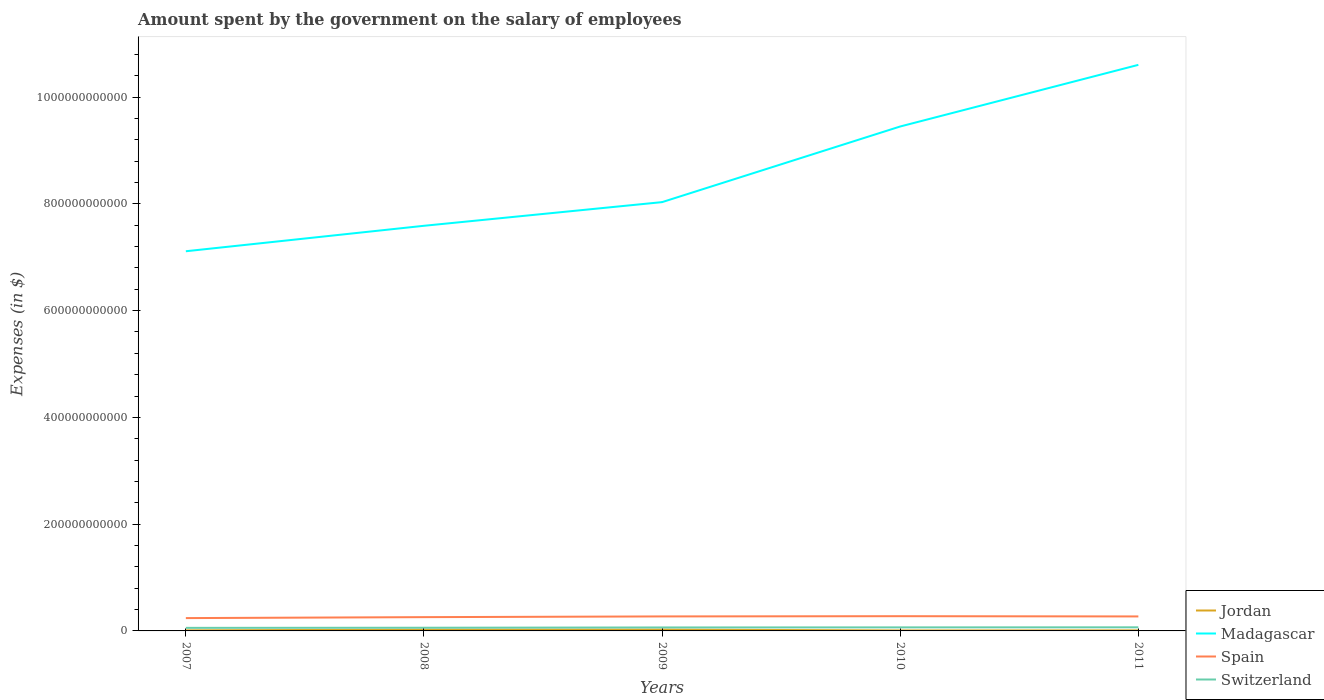How many different coloured lines are there?
Provide a short and direct response. 4. Is the number of lines equal to the number of legend labels?
Make the answer very short. Yes. Across all years, what is the maximum amount spent on the salary of employees by the government in Spain?
Offer a very short reply. 2.40e+1. What is the total amount spent on the salary of employees by the government in Jordan in the graph?
Your answer should be compact. 1.52e+09. What is the difference between the highest and the second highest amount spent on the salary of employees by the government in Spain?
Make the answer very short. 3.58e+09. What is the difference between the highest and the lowest amount spent on the salary of employees by the government in Switzerland?
Provide a short and direct response. 3. How many years are there in the graph?
Your response must be concise. 5. What is the difference between two consecutive major ticks on the Y-axis?
Ensure brevity in your answer.  2.00e+11. Are the values on the major ticks of Y-axis written in scientific E-notation?
Ensure brevity in your answer.  No. Does the graph contain any zero values?
Your answer should be very brief. No. Does the graph contain grids?
Your answer should be very brief. No. What is the title of the graph?
Provide a succinct answer. Amount spent by the government on the salary of employees. Does "Serbia" appear as one of the legend labels in the graph?
Your answer should be compact. No. What is the label or title of the X-axis?
Ensure brevity in your answer.  Years. What is the label or title of the Y-axis?
Offer a terse response. Expenses (in $). What is the Expenses (in $) in Jordan in 2007?
Provide a short and direct response. 1.07e+09. What is the Expenses (in $) in Madagascar in 2007?
Offer a terse response. 7.11e+11. What is the Expenses (in $) of Spain in 2007?
Your answer should be compact. 2.40e+1. What is the Expenses (in $) in Switzerland in 2007?
Your answer should be very brief. 5.73e+09. What is the Expenses (in $) of Jordan in 2008?
Make the answer very short. 2.39e+09. What is the Expenses (in $) of Madagascar in 2008?
Your answer should be very brief. 7.59e+11. What is the Expenses (in $) of Spain in 2008?
Provide a short and direct response. 2.58e+1. What is the Expenses (in $) in Switzerland in 2008?
Keep it short and to the point. 5.96e+09. What is the Expenses (in $) of Jordan in 2009?
Provide a succinct answer. 2.53e+09. What is the Expenses (in $) of Madagascar in 2009?
Your answer should be compact. 8.03e+11. What is the Expenses (in $) of Spain in 2009?
Ensure brevity in your answer.  2.71e+1. What is the Expenses (in $) in Switzerland in 2009?
Keep it short and to the point. 6.48e+09. What is the Expenses (in $) of Jordan in 2010?
Offer a very short reply. 8.84e+08. What is the Expenses (in $) of Madagascar in 2010?
Ensure brevity in your answer.  9.45e+11. What is the Expenses (in $) in Spain in 2010?
Offer a terse response. 2.76e+1. What is the Expenses (in $) in Switzerland in 2010?
Give a very brief answer. 6.65e+09. What is the Expenses (in $) of Jordan in 2011?
Give a very brief answer. 1.01e+09. What is the Expenses (in $) of Madagascar in 2011?
Provide a succinct answer. 1.06e+12. What is the Expenses (in $) of Spain in 2011?
Ensure brevity in your answer.  2.71e+1. What is the Expenses (in $) in Switzerland in 2011?
Provide a succinct answer. 6.75e+09. Across all years, what is the maximum Expenses (in $) of Jordan?
Make the answer very short. 2.53e+09. Across all years, what is the maximum Expenses (in $) of Madagascar?
Give a very brief answer. 1.06e+12. Across all years, what is the maximum Expenses (in $) of Spain?
Provide a short and direct response. 2.76e+1. Across all years, what is the maximum Expenses (in $) of Switzerland?
Provide a succinct answer. 6.75e+09. Across all years, what is the minimum Expenses (in $) of Jordan?
Offer a very short reply. 8.84e+08. Across all years, what is the minimum Expenses (in $) in Madagascar?
Give a very brief answer. 7.11e+11. Across all years, what is the minimum Expenses (in $) of Spain?
Provide a short and direct response. 2.40e+1. Across all years, what is the minimum Expenses (in $) in Switzerland?
Your answer should be compact. 5.73e+09. What is the total Expenses (in $) of Jordan in the graph?
Offer a terse response. 7.89e+09. What is the total Expenses (in $) of Madagascar in the graph?
Make the answer very short. 4.28e+12. What is the total Expenses (in $) of Spain in the graph?
Make the answer very short. 1.32e+11. What is the total Expenses (in $) of Switzerland in the graph?
Make the answer very short. 3.16e+1. What is the difference between the Expenses (in $) of Jordan in 2007 and that in 2008?
Your response must be concise. -1.32e+09. What is the difference between the Expenses (in $) of Madagascar in 2007 and that in 2008?
Keep it short and to the point. -4.77e+1. What is the difference between the Expenses (in $) in Spain in 2007 and that in 2008?
Provide a short and direct response. -1.80e+09. What is the difference between the Expenses (in $) of Switzerland in 2007 and that in 2008?
Provide a short and direct response. -2.25e+08. What is the difference between the Expenses (in $) of Jordan in 2007 and that in 2009?
Your response must be concise. -1.47e+09. What is the difference between the Expenses (in $) in Madagascar in 2007 and that in 2009?
Provide a short and direct response. -9.20e+1. What is the difference between the Expenses (in $) of Spain in 2007 and that in 2009?
Your answer should be compact. -3.12e+09. What is the difference between the Expenses (in $) of Switzerland in 2007 and that in 2009?
Ensure brevity in your answer.  -7.49e+08. What is the difference between the Expenses (in $) in Jordan in 2007 and that in 2010?
Keep it short and to the point. 1.84e+08. What is the difference between the Expenses (in $) in Madagascar in 2007 and that in 2010?
Your answer should be very brief. -2.34e+11. What is the difference between the Expenses (in $) in Spain in 2007 and that in 2010?
Give a very brief answer. -3.58e+09. What is the difference between the Expenses (in $) of Switzerland in 2007 and that in 2010?
Your response must be concise. -9.15e+08. What is the difference between the Expenses (in $) in Jordan in 2007 and that in 2011?
Make the answer very short. 5.42e+07. What is the difference between the Expenses (in $) in Madagascar in 2007 and that in 2011?
Keep it short and to the point. -3.49e+11. What is the difference between the Expenses (in $) of Spain in 2007 and that in 2011?
Your answer should be very brief. -3.12e+09. What is the difference between the Expenses (in $) of Switzerland in 2007 and that in 2011?
Offer a very short reply. -1.01e+09. What is the difference between the Expenses (in $) in Jordan in 2008 and that in 2009?
Keep it short and to the point. -1.44e+08. What is the difference between the Expenses (in $) in Madagascar in 2008 and that in 2009?
Offer a terse response. -4.43e+1. What is the difference between the Expenses (in $) in Spain in 2008 and that in 2009?
Your answer should be very brief. -1.32e+09. What is the difference between the Expenses (in $) of Switzerland in 2008 and that in 2009?
Your response must be concise. -5.24e+08. What is the difference between the Expenses (in $) of Jordan in 2008 and that in 2010?
Your answer should be compact. 1.50e+09. What is the difference between the Expenses (in $) in Madagascar in 2008 and that in 2010?
Make the answer very short. -1.86e+11. What is the difference between the Expenses (in $) of Spain in 2008 and that in 2010?
Provide a short and direct response. -1.78e+09. What is the difference between the Expenses (in $) in Switzerland in 2008 and that in 2010?
Your answer should be compact. -6.91e+08. What is the difference between the Expenses (in $) of Jordan in 2008 and that in 2011?
Your response must be concise. 1.38e+09. What is the difference between the Expenses (in $) of Madagascar in 2008 and that in 2011?
Make the answer very short. -3.01e+11. What is the difference between the Expenses (in $) in Spain in 2008 and that in 2011?
Your response must be concise. -1.32e+09. What is the difference between the Expenses (in $) in Switzerland in 2008 and that in 2011?
Offer a very short reply. -7.88e+08. What is the difference between the Expenses (in $) of Jordan in 2009 and that in 2010?
Your answer should be very brief. 1.65e+09. What is the difference between the Expenses (in $) of Madagascar in 2009 and that in 2010?
Make the answer very short. -1.42e+11. What is the difference between the Expenses (in $) in Spain in 2009 and that in 2010?
Your answer should be compact. -4.54e+08. What is the difference between the Expenses (in $) of Switzerland in 2009 and that in 2010?
Provide a succinct answer. -1.66e+08. What is the difference between the Expenses (in $) of Jordan in 2009 and that in 2011?
Your response must be concise. 1.52e+09. What is the difference between the Expenses (in $) in Madagascar in 2009 and that in 2011?
Offer a terse response. -2.57e+11. What is the difference between the Expenses (in $) of Spain in 2009 and that in 2011?
Offer a terse response. 9.00e+06. What is the difference between the Expenses (in $) of Switzerland in 2009 and that in 2011?
Ensure brevity in your answer.  -2.64e+08. What is the difference between the Expenses (in $) of Jordan in 2010 and that in 2011?
Your response must be concise. -1.30e+08. What is the difference between the Expenses (in $) of Madagascar in 2010 and that in 2011?
Your answer should be compact. -1.15e+11. What is the difference between the Expenses (in $) in Spain in 2010 and that in 2011?
Your answer should be very brief. 4.63e+08. What is the difference between the Expenses (in $) of Switzerland in 2010 and that in 2011?
Give a very brief answer. -9.73e+07. What is the difference between the Expenses (in $) of Jordan in 2007 and the Expenses (in $) of Madagascar in 2008?
Your answer should be compact. -7.58e+11. What is the difference between the Expenses (in $) in Jordan in 2007 and the Expenses (in $) in Spain in 2008?
Provide a succinct answer. -2.48e+1. What is the difference between the Expenses (in $) of Jordan in 2007 and the Expenses (in $) of Switzerland in 2008?
Offer a very short reply. -4.89e+09. What is the difference between the Expenses (in $) of Madagascar in 2007 and the Expenses (in $) of Spain in 2008?
Keep it short and to the point. 6.85e+11. What is the difference between the Expenses (in $) of Madagascar in 2007 and the Expenses (in $) of Switzerland in 2008?
Offer a very short reply. 7.05e+11. What is the difference between the Expenses (in $) in Spain in 2007 and the Expenses (in $) in Switzerland in 2008?
Your response must be concise. 1.81e+1. What is the difference between the Expenses (in $) in Jordan in 2007 and the Expenses (in $) in Madagascar in 2009?
Your answer should be compact. -8.02e+11. What is the difference between the Expenses (in $) in Jordan in 2007 and the Expenses (in $) in Spain in 2009?
Ensure brevity in your answer.  -2.61e+1. What is the difference between the Expenses (in $) of Jordan in 2007 and the Expenses (in $) of Switzerland in 2009?
Ensure brevity in your answer.  -5.42e+09. What is the difference between the Expenses (in $) in Madagascar in 2007 and the Expenses (in $) in Spain in 2009?
Your answer should be very brief. 6.84e+11. What is the difference between the Expenses (in $) in Madagascar in 2007 and the Expenses (in $) in Switzerland in 2009?
Your response must be concise. 7.05e+11. What is the difference between the Expenses (in $) of Spain in 2007 and the Expenses (in $) of Switzerland in 2009?
Offer a terse response. 1.75e+1. What is the difference between the Expenses (in $) in Jordan in 2007 and the Expenses (in $) in Madagascar in 2010?
Make the answer very short. -9.44e+11. What is the difference between the Expenses (in $) in Jordan in 2007 and the Expenses (in $) in Spain in 2010?
Offer a very short reply. -2.65e+1. What is the difference between the Expenses (in $) of Jordan in 2007 and the Expenses (in $) of Switzerland in 2010?
Your answer should be compact. -5.58e+09. What is the difference between the Expenses (in $) of Madagascar in 2007 and the Expenses (in $) of Spain in 2010?
Keep it short and to the point. 6.84e+11. What is the difference between the Expenses (in $) in Madagascar in 2007 and the Expenses (in $) in Switzerland in 2010?
Your answer should be very brief. 7.05e+11. What is the difference between the Expenses (in $) in Spain in 2007 and the Expenses (in $) in Switzerland in 2010?
Ensure brevity in your answer.  1.74e+1. What is the difference between the Expenses (in $) in Jordan in 2007 and the Expenses (in $) in Madagascar in 2011?
Provide a short and direct response. -1.06e+12. What is the difference between the Expenses (in $) of Jordan in 2007 and the Expenses (in $) of Spain in 2011?
Ensure brevity in your answer.  -2.61e+1. What is the difference between the Expenses (in $) in Jordan in 2007 and the Expenses (in $) in Switzerland in 2011?
Your answer should be very brief. -5.68e+09. What is the difference between the Expenses (in $) in Madagascar in 2007 and the Expenses (in $) in Spain in 2011?
Your response must be concise. 6.84e+11. What is the difference between the Expenses (in $) in Madagascar in 2007 and the Expenses (in $) in Switzerland in 2011?
Your answer should be compact. 7.04e+11. What is the difference between the Expenses (in $) of Spain in 2007 and the Expenses (in $) of Switzerland in 2011?
Provide a succinct answer. 1.73e+1. What is the difference between the Expenses (in $) of Jordan in 2008 and the Expenses (in $) of Madagascar in 2009?
Your response must be concise. -8.01e+11. What is the difference between the Expenses (in $) in Jordan in 2008 and the Expenses (in $) in Spain in 2009?
Provide a short and direct response. -2.48e+1. What is the difference between the Expenses (in $) in Jordan in 2008 and the Expenses (in $) in Switzerland in 2009?
Ensure brevity in your answer.  -4.10e+09. What is the difference between the Expenses (in $) of Madagascar in 2008 and the Expenses (in $) of Spain in 2009?
Provide a short and direct response. 7.32e+11. What is the difference between the Expenses (in $) in Madagascar in 2008 and the Expenses (in $) in Switzerland in 2009?
Your answer should be very brief. 7.52e+11. What is the difference between the Expenses (in $) in Spain in 2008 and the Expenses (in $) in Switzerland in 2009?
Provide a succinct answer. 1.93e+1. What is the difference between the Expenses (in $) in Jordan in 2008 and the Expenses (in $) in Madagascar in 2010?
Offer a very short reply. -9.43e+11. What is the difference between the Expenses (in $) of Jordan in 2008 and the Expenses (in $) of Spain in 2010?
Ensure brevity in your answer.  -2.52e+1. What is the difference between the Expenses (in $) in Jordan in 2008 and the Expenses (in $) in Switzerland in 2010?
Your response must be concise. -4.26e+09. What is the difference between the Expenses (in $) in Madagascar in 2008 and the Expenses (in $) in Spain in 2010?
Make the answer very short. 7.31e+11. What is the difference between the Expenses (in $) in Madagascar in 2008 and the Expenses (in $) in Switzerland in 2010?
Ensure brevity in your answer.  7.52e+11. What is the difference between the Expenses (in $) in Spain in 2008 and the Expenses (in $) in Switzerland in 2010?
Provide a short and direct response. 1.92e+1. What is the difference between the Expenses (in $) in Jordan in 2008 and the Expenses (in $) in Madagascar in 2011?
Your answer should be compact. -1.06e+12. What is the difference between the Expenses (in $) in Jordan in 2008 and the Expenses (in $) in Spain in 2011?
Make the answer very short. -2.48e+1. What is the difference between the Expenses (in $) of Jordan in 2008 and the Expenses (in $) of Switzerland in 2011?
Make the answer very short. -4.36e+09. What is the difference between the Expenses (in $) of Madagascar in 2008 and the Expenses (in $) of Spain in 2011?
Keep it short and to the point. 7.32e+11. What is the difference between the Expenses (in $) in Madagascar in 2008 and the Expenses (in $) in Switzerland in 2011?
Provide a short and direct response. 7.52e+11. What is the difference between the Expenses (in $) in Spain in 2008 and the Expenses (in $) in Switzerland in 2011?
Your answer should be compact. 1.91e+1. What is the difference between the Expenses (in $) of Jordan in 2009 and the Expenses (in $) of Madagascar in 2010?
Provide a succinct answer. -9.42e+11. What is the difference between the Expenses (in $) in Jordan in 2009 and the Expenses (in $) in Spain in 2010?
Give a very brief answer. -2.51e+1. What is the difference between the Expenses (in $) in Jordan in 2009 and the Expenses (in $) in Switzerland in 2010?
Provide a succinct answer. -4.12e+09. What is the difference between the Expenses (in $) in Madagascar in 2009 and the Expenses (in $) in Spain in 2010?
Offer a very short reply. 7.76e+11. What is the difference between the Expenses (in $) in Madagascar in 2009 and the Expenses (in $) in Switzerland in 2010?
Your response must be concise. 7.97e+11. What is the difference between the Expenses (in $) in Spain in 2009 and the Expenses (in $) in Switzerland in 2010?
Your response must be concise. 2.05e+1. What is the difference between the Expenses (in $) in Jordan in 2009 and the Expenses (in $) in Madagascar in 2011?
Your response must be concise. -1.06e+12. What is the difference between the Expenses (in $) of Jordan in 2009 and the Expenses (in $) of Spain in 2011?
Keep it short and to the point. -2.46e+1. What is the difference between the Expenses (in $) of Jordan in 2009 and the Expenses (in $) of Switzerland in 2011?
Make the answer very short. -4.21e+09. What is the difference between the Expenses (in $) of Madagascar in 2009 and the Expenses (in $) of Spain in 2011?
Offer a very short reply. 7.76e+11. What is the difference between the Expenses (in $) in Madagascar in 2009 and the Expenses (in $) in Switzerland in 2011?
Keep it short and to the point. 7.96e+11. What is the difference between the Expenses (in $) in Spain in 2009 and the Expenses (in $) in Switzerland in 2011?
Your answer should be very brief. 2.04e+1. What is the difference between the Expenses (in $) of Jordan in 2010 and the Expenses (in $) of Madagascar in 2011?
Provide a succinct answer. -1.06e+12. What is the difference between the Expenses (in $) in Jordan in 2010 and the Expenses (in $) in Spain in 2011?
Make the answer very short. -2.63e+1. What is the difference between the Expenses (in $) of Jordan in 2010 and the Expenses (in $) of Switzerland in 2011?
Ensure brevity in your answer.  -5.86e+09. What is the difference between the Expenses (in $) in Madagascar in 2010 and the Expenses (in $) in Spain in 2011?
Keep it short and to the point. 9.18e+11. What is the difference between the Expenses (in $) of Madagascar in 2010 and the Expenses (in $) of Switzerland in 2011?
Provide a short and direct response. 9.38e+11. What is the difference between the Expenses (in $) of Spain in 2010 and the Expenses (in $) of Switzerland in 2011?
Offer a very short reply. 2.09e+1. What is the average Expenses (in $) in Jordan per year?
Your response must be concise. 1.58e+09. What is the average Expenses (in $) of Madagascar per year?
Offer a terse response. 8.56e+11. What is the average Expenses (in $) in Spain per year?
Your response must be concise. 2.63e+1. What is the average Expenses (in $) of Switzerland per year?
Give a very brief answer. 6.32e+09. In the year 2007, what is the difference between the Expenses (in $) in Jordan and Expenses (in $) in Madagascar?
Offer a very short reply. -7.10e+11. In the year 2007, what is the difference between the Expenses (in $) of Jordan and Expenses (in $) of Spain?
Provide a succinct answer. -2.30e+1. In the year 2007, what is the difference between the Expenses (in $) of Jordan and Expenses (in $) of Switzerland?
Your answer should be very brief. -4.67e+09. In the year 2007, what is the difference between the Expenses (in $) of Madagascar and Expenses (in $) of Spain?
Your answer should be very brief. 6.87e+11. In the year 2007, what is the difference between the Expenses (in $) of Madagascar and Expenses (in $) of Switzerland?
Your answer should be very brief. 7.05e+11. In the year 2007, what is the difference between the Expenses (in $) in Spain and Expenses (in $) in Switzerland?
Your response must be concise. 1.83e+1. In the year 2008, what is the difference between the Expenses (in $) of Jordan and Expenses (in $) of Madagascar?
Offer a terse response. -7.57e+11. In the year 2008, what is the difference between the Expenses (in $) in Jordan and Expenses (in $) in Spain?
Provide a succinct answer. -2.34e+1. In the year 2008, what is the difference between the Expenses (in $) in Jordan and Expenses (in $) in Switzerland?
Give a very brief answer. -3.57e+09. In the year 2008, what is the difference between the Expenses (in $) of Madagascar and Expenses (in $) of Spain?
Offer a very short reply. 7.33e+11. In the year 2008, what is the difference between the Expenses (in $) of Madagascar and Expenses (in $) of Switzerland?
Your answer should be very brief. 7.53e+11. In the year 2008, what is the difference between the Expenses (in $) of Spain and Expenses (in $) of Switzerland?
Keep it short and to the point. 1.99e+1. In the year 2009, what is the difference between the Expenses (in $) in Jordan and Expenses (in $) in Madagascar?
Offer a terse response. -8.01e+11. In the year 2009, what is the difference between the Expenses (in $) of Jordan and Expenses (in $) of Spain?
Provide a succinct answer. -2.46e+1. In the year 2009, what is the difference between the Expenses (in $) in Jordan and Expenses (in $) in Switzerland?
Provide a short and direct response. -3.95e+09. In the year 2009, what is the difference between the Expenses (in $) in Madagascar and Expenses (in $) in Spain?
Provide a succinct answer. 7.76e+11. In the year 2009, what is the difference between the Expenses (in $) in Madagascar and Expenses (in $) in Switzerland?
Keep it short and to the point. 7.97e+11. In the year 2009, what is the difference between the Expenses (in $) in Spain and Expenses (in $) in Switzerland?
Give a very brief answer. 2.07e+1. In the year 2010, what is the difference between the Expenses (in $) of Jordan and Expenses (in $) of Madagascar?
Keep it short and to the point. -9.44e+11. In the year 2010, what is the difference between the Expenses (in $) of Jordan and Expenses (in $) of Spain?
Your answer should be very brief. -2.67e+1. In the year 2010, what is the difference between the Expenses (in $) in Jordan and Expenses (in $) in Switzerland?
Provide a short and direct response. -5.77e+09. In the year 2010, what is the difference between the Expenses (in $) in Madagascar and Expenses (in $) in Spain?
Provide a short and direct response. 9.17e+11. In the year 2010, what is the difference between the Expenses (in $) of Madagascar and Expenses (in $) of Switzerland?
Offer a terse response. 9.38e+11. In the year 2010, what is the difference between the Expenses (in $) in Spain and Expenses (in $) in Switzerland?
Provide a short and direct response. 2.10e+1. In the year 2011, what is the difference between the Expenses (in $) of Jordan and Expenses (in $) of Madagascar?
Provide a succinct answer. -1.06e+12. In the year 2011, what is the difference between the Expenses (in $) of Jordan and Expenses (in $) of Spain?
Your answer should be very brief. -2.61e+1. In the year 2011, what is the difference between the Expenses (in $) of Jordan and Expenses (in $) of Switzerland?
Ensure brevity in your answer.  -5.73e+09. In the year 2011, what is the difference between the Expenses (in $) in Madagascar and Expenses (in $) in Spain?
Your answer should be compact. 1.03e+12. In the year 2011, what is the difference between the Expenses (in $) in Madagascar and Expenses (in $) in Switzerland?
Your response must be concise. 1.05e+12. In the year 2011, what is the difference between the Expenses (in $) of Spain and Expenses (in $) of Switzerland?
Offer a terse response. 2.04e+1. What is the ratio of the Expenses (in $) of Jordan in 2007 to that in 2008?
Keep it short and to the point. 0.45. What is the ratio of the Expenses (in $) of Madagascar in 2007 to that in 2008?
Ensure brevity in your answer.  0.94. What is the ratio of the Expenses (in $) in Spain in 2007 to that in 2008?
Keep it short and to the point. 0.93. What is the ratio of the Expenses (in $) of Switzerland in 2007 to that in 2008?
Ensure brevity in your answer.  0.96. What is the ratio of the Expenses (in $) in Jordan in 2007 to that in 2009?
Your response must be concise. 0.42. What is the ratio of the Expenses (in $) of Madagascar in 2007 to that in 2009?
Keep it short and to the point. 0.89. What is the ratio of the Expenses (in $) of Spain in 2007 to that in 2009?
Your response must be concise. 0.88. What is the ratio of the Expenses (in $) of Switzerland in 2007 to that in 2009?
Provide a succinct answer. 0.88. What is the ratio of the Expenses (in $) in Jordan in 2007 to that in 2010?
Ensure brevity in your answer.  1.21. What is the ratio of the Expenses (in $) of Madagascar in 2007 to that in 2010?
Make the answer very short. 0.75. What is the ratio of the Expenses (in $) of Spain in 2007 to that in 2010?
Give a very brief answer. 0.87. What is the ratio of the Expenses (in $) of Switzerland in 2007 to that in 2010?
Your response must be concise. 0.86. What is the ratio of the Expenses (in $) in Jordan in 2007 to that in 2011?
Offer a terse response. 1.05. What is the ratio of the Expenses (in $) of Madagascar in 2007 to that in 2011?
Provide a short and direct response. 0.67. What is the ratio of the Expenses (in $) of Spain in 2007 to that in 2011?
Keep it short and to the point. 0.89. What is the ratio of the Expenses (in $) in Switzerland in 2007 to that in 2011?
Give a very brief answer. 0.85. What is the ratio of the Expenses (in $) in Jordan in 2008 to that in 2009?
Your answer should be compact. 0.94. What is the ratio of the Expenses (in $) of Madagascar in 2008 to that in 2009?
Keep it short and to the point. 0.94. What is the ratio of the Expenses (in $) of Spain in 2008 to that in 2009?
Make the answer very short. 0.95. What is the ratio of the Expenses (in $) of Switzerland in 2008 to that in 2009?
Ensure brevity in your answer.  0.92. What is the ratio of the Expenses (in $) in Jordan in 2008 to that in 2010?
Your response must be concise. 2.7. What is the ratio of the Expenses (in $) of Madagascar in 2008 to that in 2010?
Your response must be concise. 0.8. What is the ratio of the Expenses (in $) of Spain in 2008 to that in 2010?
Provide a succinct answer. 0.94. What is the ratio of the Expenses (in $) of Switzerland in 2008 to that in 2010?
Give a very brief answer. 0.9. What is the ratio of the Expenses (in $) of Jordan in 2008 to that in 2011?
Keep it short and to the point. 2.36. What is the ratio of the Expenses (in $) in Madagascar in 2008 to that in 2011?
Keep it short and to the point. 0.72. What is the ratio of the Expenses (in $) of Spain in 2008 to that in 2011?
Provide a short and direct response. 0.95. What is the ratio of the Expenses (in $) in Switzerland in 2008 to that in 2011?
Ensure brevity in your answer.  0.88. What is the ratio of the Expenses (in $) of Jordan in 2009 to that in 2010?
Your response must be concise. 2.87. What is the ratio of the Expenses (in $) in Madagascar in 2009 to that in 2010?
Offer a very short reply. 0.85. What is the ratio of the Expenses (in $) of Spain in 2009 to that in 2010?
Give a very brief answer. 0.98. What is the ratio of the Expenses (in $) in Switzerland in 2009 to that in 2010?
Give a very brief answer. 0.97. What is the ratio of the Expenses (in $) in Jordan in 2009 to that in 2011?
Provide a short and direct response. 2.5. What is the ratio of the Expenses (in $) in Madagascar in 2009 to that in 2011?
Your response must be concise. 0.76. What is the ratio of the Expenses (in $) in Switzerland in 2009 to that in 2011?
Ensure brevity in your answer.  0.96. What is the ratio of the Expenses (in $) of Jordan in 2010 to that in 2011?
Provide a short and direct response. 0.87. What is the ratio of the Expenses (in $) of Madagascar in 2010 to that in 2011?
Give a very brief answer. 0.89. What is the ratio of the Expenses (in $) in Spain in 2010 to that in 2011?
Your answer should be very brief. 1.02. What is the ratio of the Expenses (in $) in Switzerland in 2010 to that in 2011?
Your answer should be compact. 0.99. What is the difference between the highest and the second highest Expenses (in $) of Jordan?
Make the answer very short. 1.44e+08. What is the difference between the highest and the second highest Expenses (in $) in Madagascar?
Provide a succinct answer. 1.15e+11. What is the difference between the highest and the second highest Expenses (in $) in Spain?
Keep it short and to the point. 4.54e+08. What is the difference between the highest and the second highest Expenses (in $) in Switzerland?
Ensure brevity in your answer.  9.73e+07. What is the difference between the highest and the lowest Expenses (in $) of Jordan?
Offer a very short reply. 1.65e+09. What is the difference between the highest and the lowest Expenses (in $) of Madagascar?
Keep it short and to the point. 3.49e+11. What is the difference between the highest and the lowest Expenses (in $) of Spain?
Provide a short and direct response. 3.58e+09. What is the difference between the highest and the lowest Expenses (in $) in Switzerland?
Your answer should be compact. 1.01e+09. 